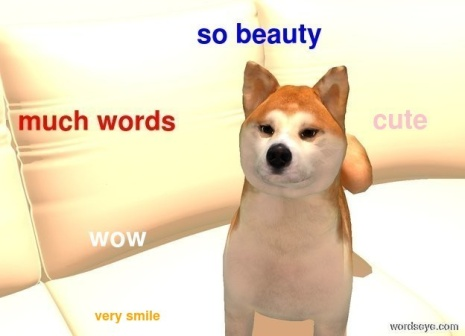Can you elaborate on the elements of the picture provided? The image portrays a Shiba Inu dog, a breed known for its distinct, fox-like appearance. The dog is positioned comfortably on a white couch with its head tilted slightly to the side, suggesting a state of curiosity or attentiveness. The Shiba Inu has cream-colored fur with subtle tan highlights around its ears and face, contributing to its expressive look.

In the foreground, various phrases in an array of colors and sizes overlay the image. The playful phrases like "so beauty", "much words", "cute", "WOW", and "very smile" are scattered across the scene. These expressions seem to serve as a humorous commentary on the dog's appearance and demeanor.

The background displays a gradient blending from a warm orange hue at the top to a lighter yellow at the bottom, creating a cheerful and uplifting ambiance for the image. The overall composition of the image is reminiscent of an internet meme, likely part of the 'Doge' meme trend. This meme style humorously uses broken English and colorful Comic Sans text to represent the Shiba Inu's imagined internal monologue, adding a layer of amusing and whimsical context. 